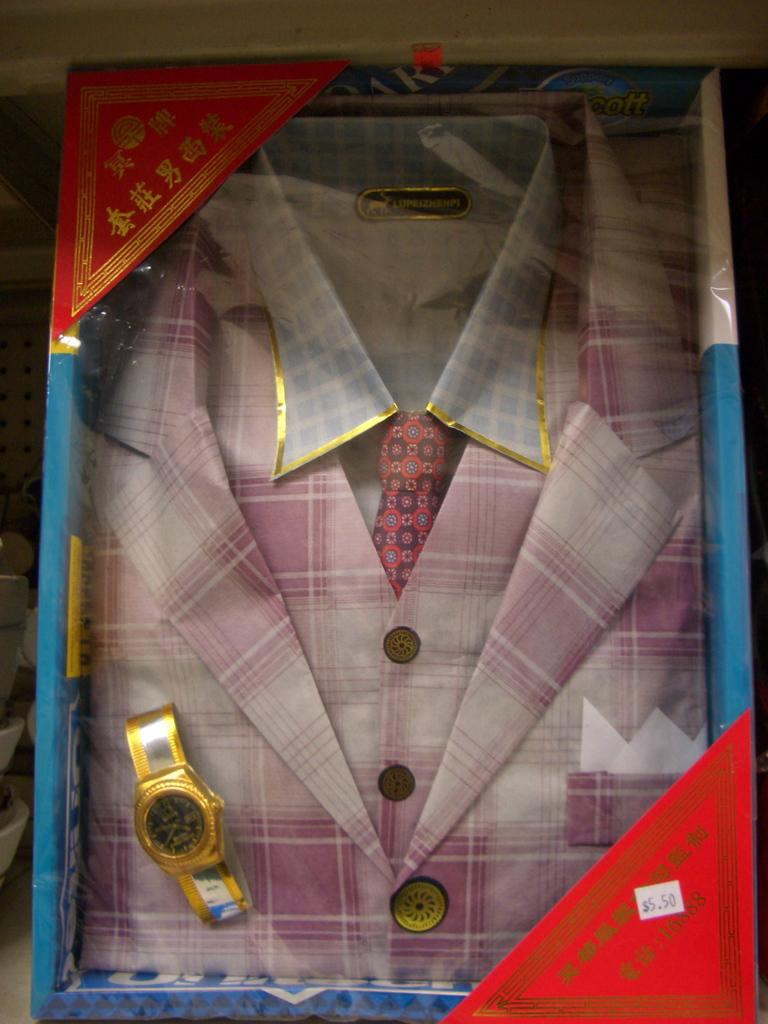<image>
Create a compact narrative representing the image presented. A shirt with the tag lupeizhenpi displayed nicely with a watch in a box. 